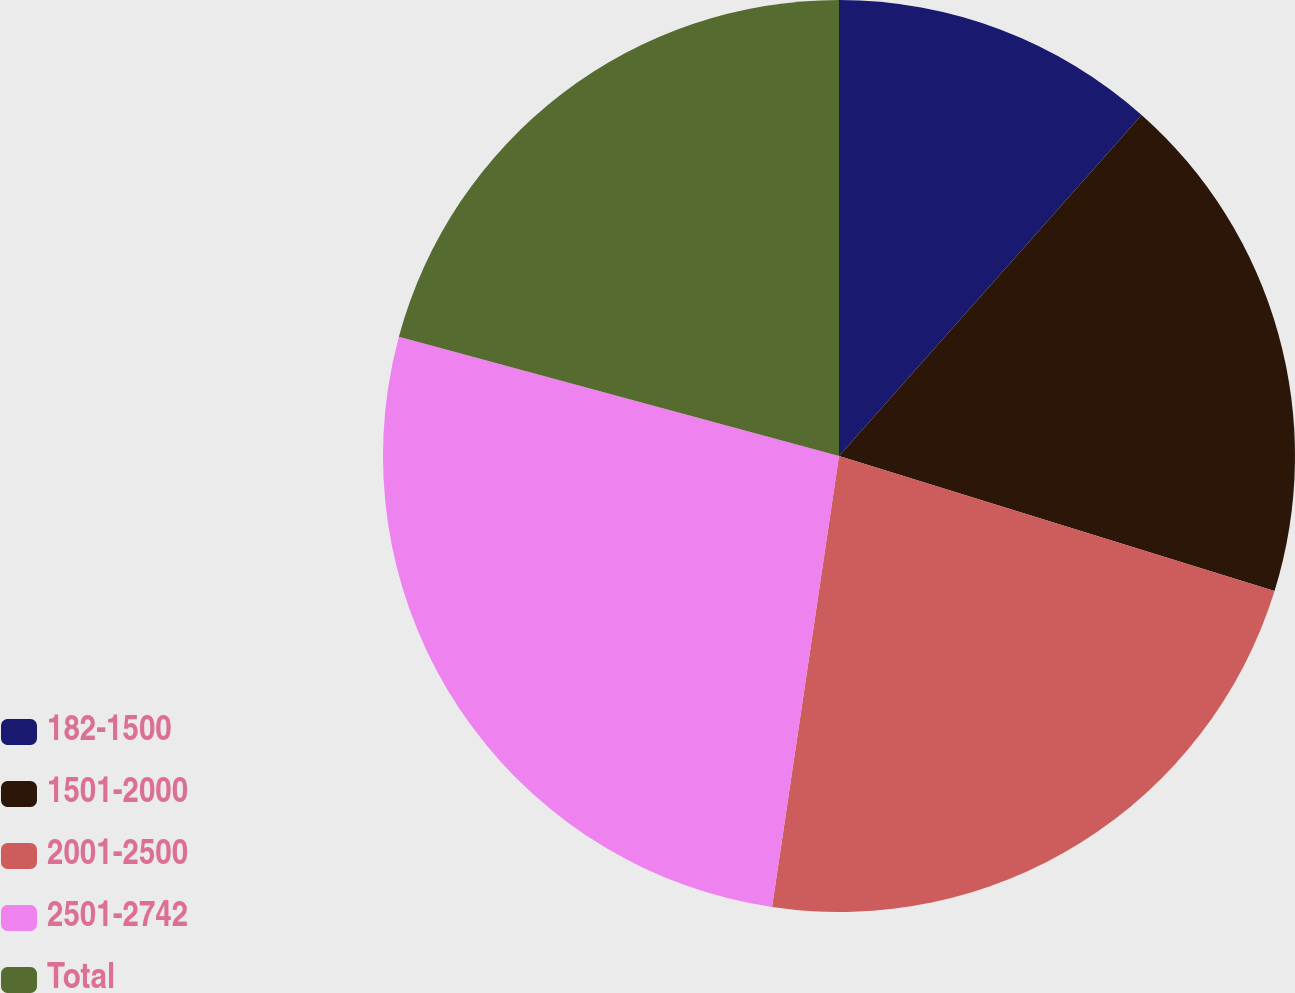Convert chart. <chart><loc_0><loc_0><loc_500><loc_500><pie_chart><fcel>182-1500<fcel>1501-2000<fcel>2001-2500<fcel>2501-2742<fcel>Total<nl><fcel>11.55%<fcel>18.24%<fcel>22.56%<fcel>26.87%<fcel>20.79%<nl></chart> 